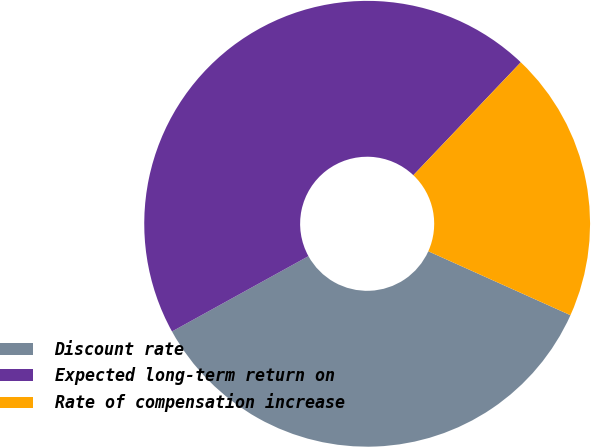Convert chart to OTSL. <chart><loc_0><loc_0><loc_500><loc_500><pie_chart><fcel>Discount rate<fcel>Expected long-term return on<fcel>Rate of compensation increase<nl><fcel>35.25%<fcel>45.13%<fcel>19.62%<nl></chart> 